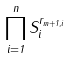Convert formula to latex. <formula><loc_0><loc_0><loc_500><loc_500>\prod ^ { n } _ { i = 1 } S ^ { r _ { m + 1 , i } } _ { i }</formula> 